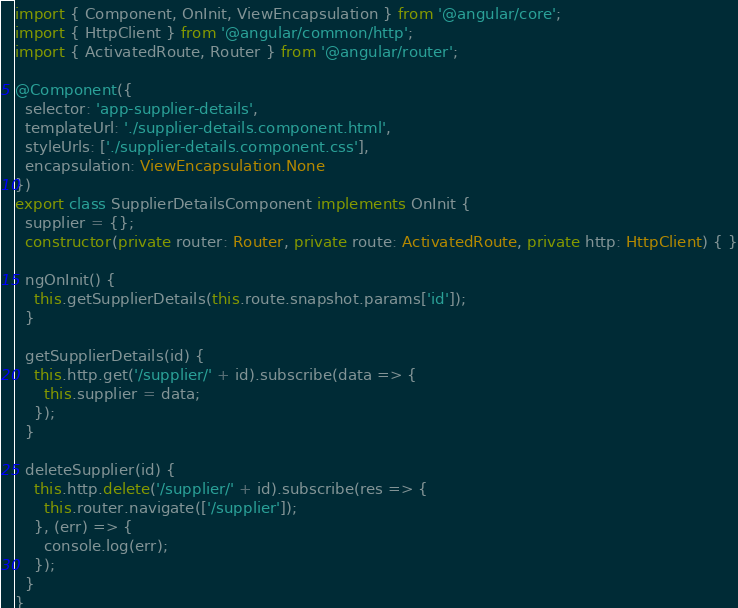Convert code to text. <code><loc_0><loc_0><loc_500><loc_500><_TypeScript_>import { Component, OnInit, ViewEncapsulation } from '@angular/core';
import { HttpClient } from '@angular/common/http';
import { ActivatedRoute, Router } from '@angular/router';

@Component({
  selector: 'app-supplier-details',
  templateUrl: './supplier-details.component.html',
  styleUrls: ['./supplier-details.component.css'],
  encapsulation: ViewEncapsulation.None
})
export class SupplierDetailsComponent implements OnInit {
  supplier = {};
  constructor(private router: Router, private route: ActivatedRoute, private http: HttpClient) { }

  ngOnInit() {
    this.getSupplierDetails(this.route.snapshot.params['id']);
  }

  getSupplierDetails(id) {
    this.http.get('/supplier/' + id).subscribe(data => {
      this.supplier = data;
    });
  }

  deleteSupplier(id) {
    this.http.delete('/supplier/' + id).subscribe(res => {
      this.router.navigate(['/supplier']);
    }, (err) => {
      console.log(err);
    });
  }
}</code> 